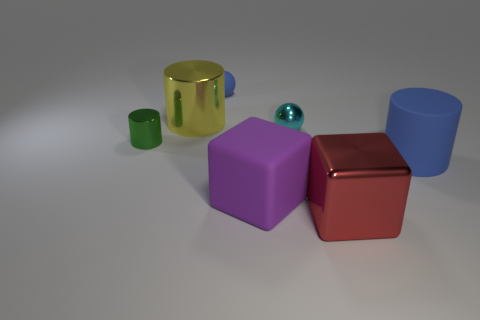Add 1 yellow cubes. How many objects exist? 8 Subtract all cubes. How many objects are left? 5 Subtract all small red balls. Subtract all big yellow shiny objects. How many objects are left? 6 Add 2 rubber balls. How many rubber balls are left? 3 Add 1 purple things. How many purple things exist? 2 Subtract 0 yellow cubes. How many objects are left? 7 